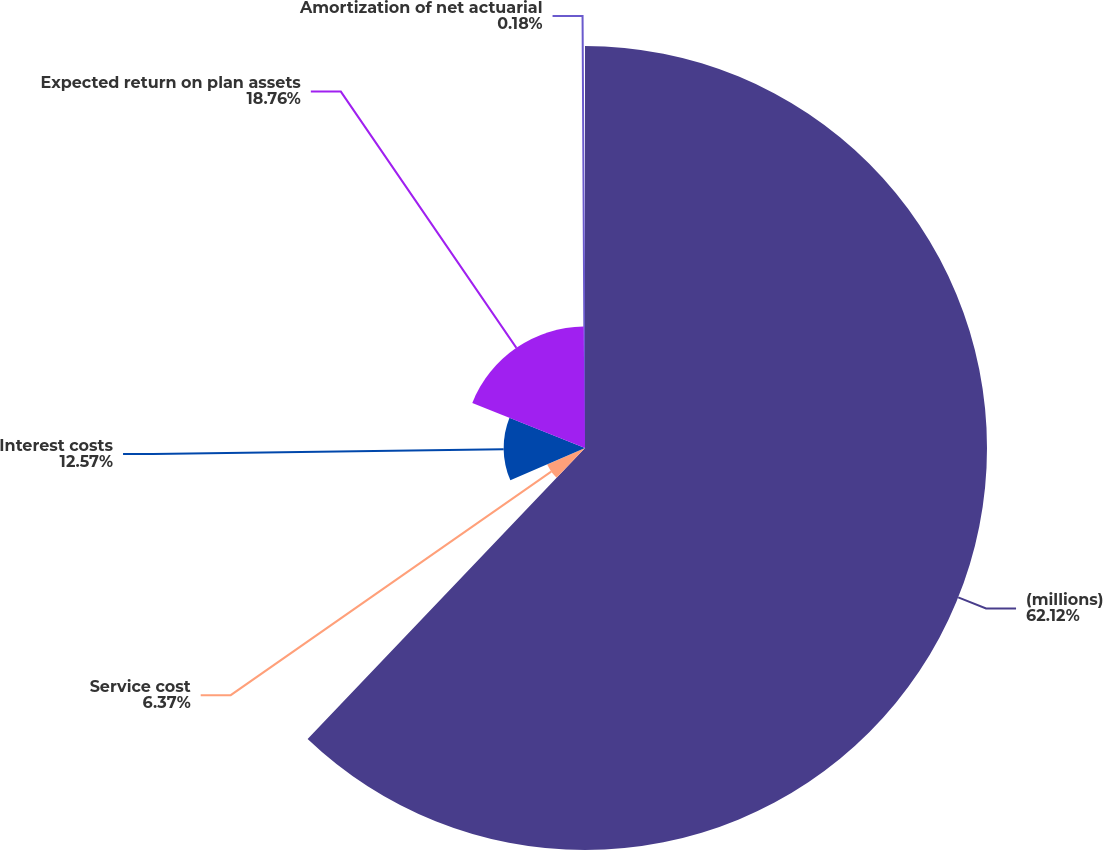Convert chart to OTSL. <chart><loc_0><loc_0><loc_500><loc_500><pie_chart><fcel>(millions)<fcel>Service cost<fcel>Interest costs<fcel>Expected return on plan assets<fcel>Amortization of net actuarial<nl><fcel>62.12%<fcel>6.37%<fcel>12.57%<fcel>18.76%<fcel>0.18%<nl></chart> 